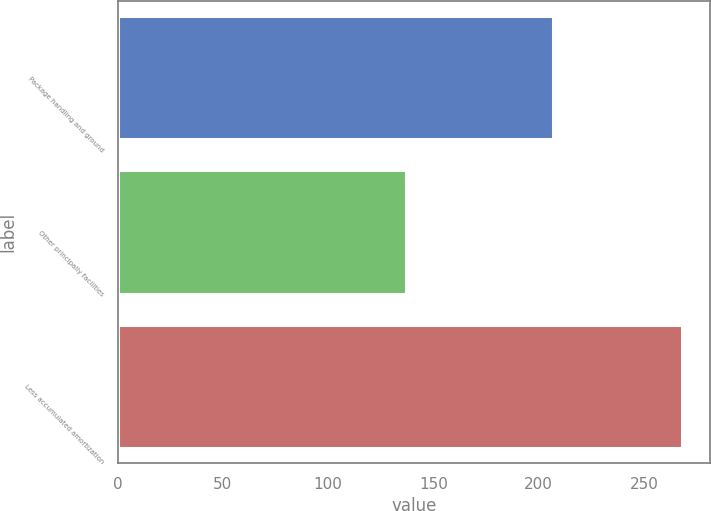Convert chart. <chart><loc_0><loc_0><loc_500><loc_500><bar_chart><fcel>Package handling and ground<fcel>Other principally facilities<fcel>Less accumulated amortization<nl><fcel>207<fcel>137<fcel>268<nl></chart> 